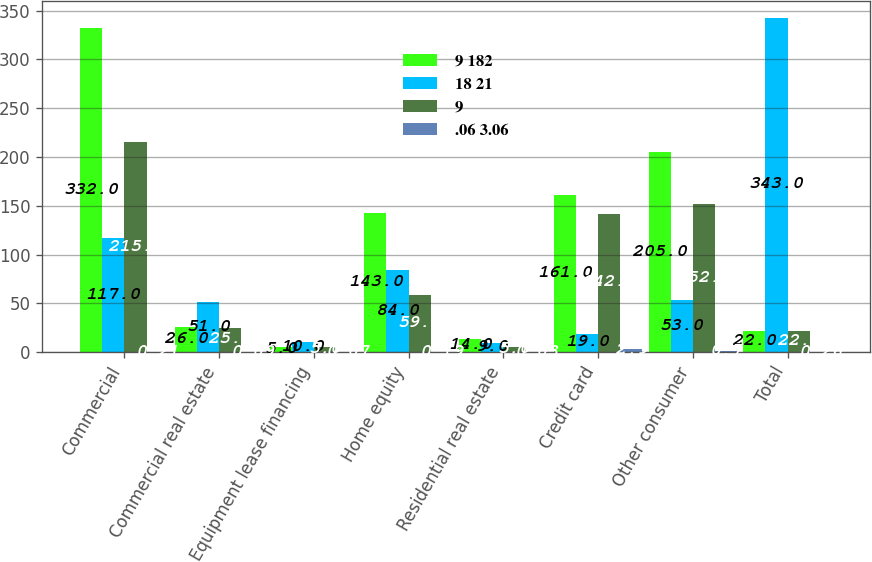<chart> <loc_0><loc_0><loc_500><loc_500><stacked_bar_chart><ecel><fcel>Commercial<fcel>Commercial real estate<fcel>Equipment lease financing<fcel>Home equity<fcel>Residential real estate<fcel>Credit card<fcel>Other consumer<fcel>Total<nl><fcel>9 182<fcel>332<fcel>26<fcel>5<fcel>143<fcel>14<fcel>161<fcel>205<fcel>22<nl><fcel>18 21<fcel>117<fcel>51<fcel>10<fcel>84<fcel>9<fcel>19<fcel>53<fcel>343<nl><fcel>9<fcel>215<fcel>25<fcel>5<fcel>59<fcel>5<fcel>142<fcel>152<fcel>22<nl><fcel>.06 3.06<fcel>0.21<fcel>0.09<fcel>0.07<fcel>0.19<fcel>0.03<fcel>2.9<fcel>0.7<fcel>0.26<nl></chart> 